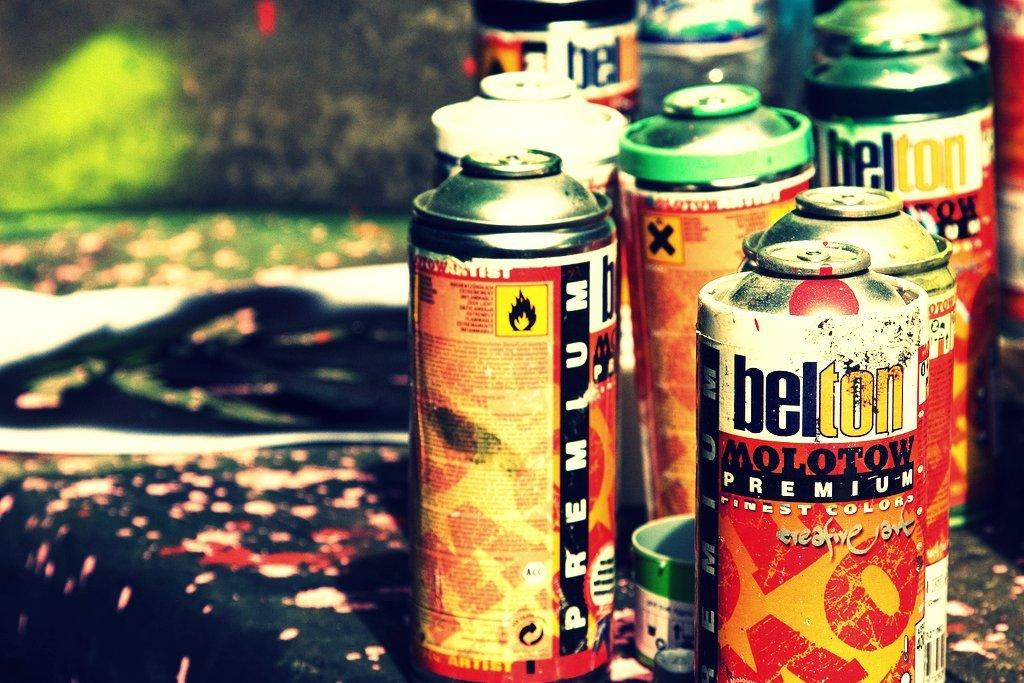Provide a one-sentence caption for the provided image. Several belton molotow premium spray paint cans sitting on a messy table. 